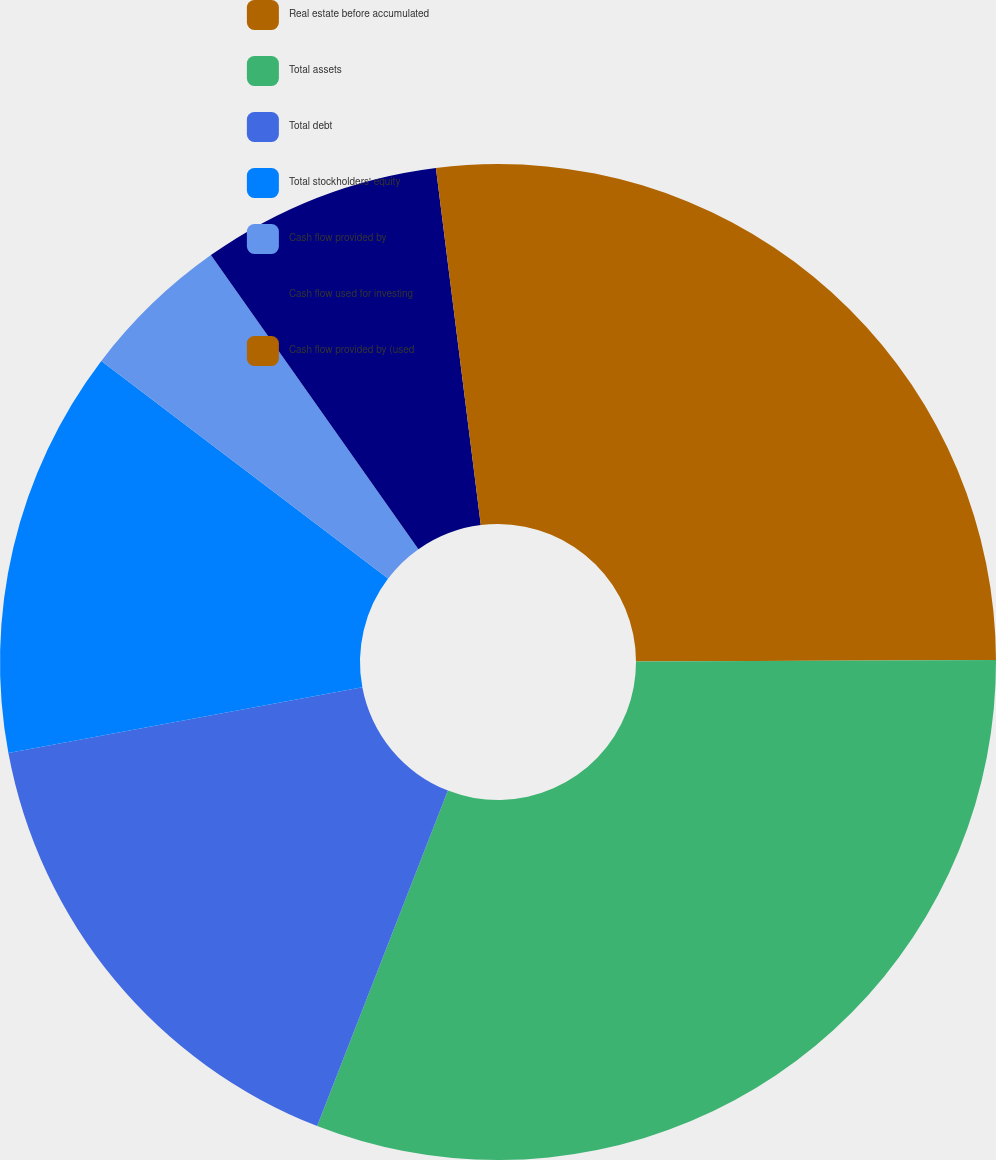Convert chart to OTSL. <chart><loc_0><loc_0><loc_500><loc_500><pie_chart><fcel>Real estate before accumulated<fcel>Total assets<fcel>Total debt<fcel>Total stockholders' equity<fcel>Cash flow provided by<fcel>Cash flow used for investing<fcel>Cash flow provided by (used<nl><fcel>24.94%<fcel>30.98%<fcel>16.16%<fcel>13.26%<fcel>4.89%<fcel>7.79%<fcel>1.99%<nl></chart> 